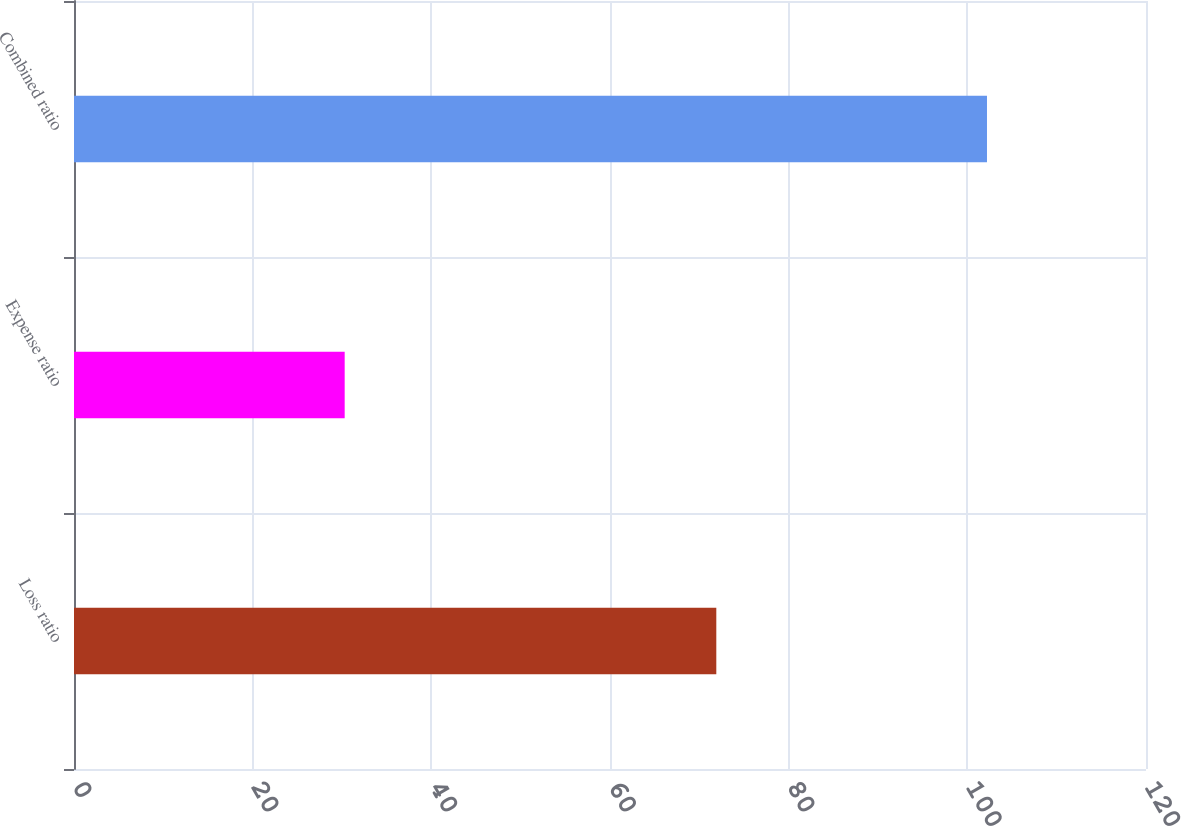<chart> <loc_0><loc_0><loc_500><loc_500><bar_chart><fcel>Loss ratio<fcel>Expense ratio<fcel>Combined ratio<nl><fcel>71.9<fcel>30.3<fcel>102.2<nl></chart> 